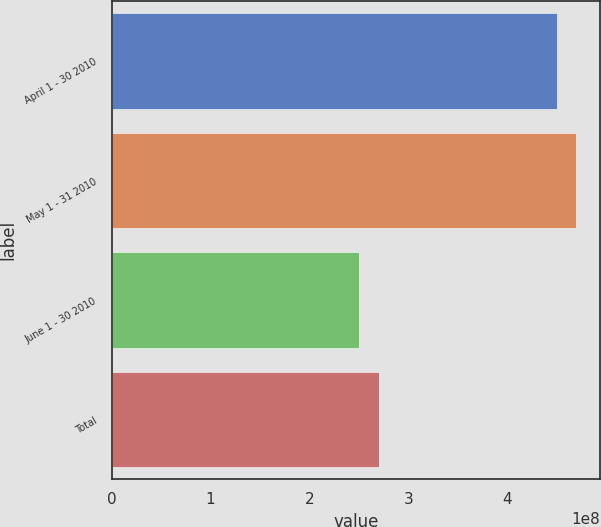<chart> <loc_0><loc_0><loc_500><loc_500><bar_chart><fcel>April 1 - 30 2010<fcel>May 1 - 31 2010<fcel>June 1 - 30 2010<fcel>Total<nl><fcel>4.5e+08<fcel>4.69991e+08<fcel>2.50089e+08<fcel>2.7008e+08<nl></chart> 